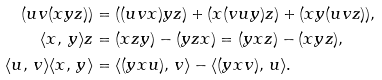<formula> <loc_0><loc_0><loc_500><loc_500>( u v ( x y z ) ) & = ( ( u v x ) y z ) + ( x ( v u y ) z ) + ( x y ( u v z ) ) , \\ \langle x , \, y \rangle z & = ( x z y ) - ( y z x ) = ( y x z ) - ( x y z ) , \\ \langle u , \, v \rangle \langle x , \, y \rangle & = \langle ( y x u ) , \, v \rangle - \langle ( y x v ) , \, u \rangle .</formula> 